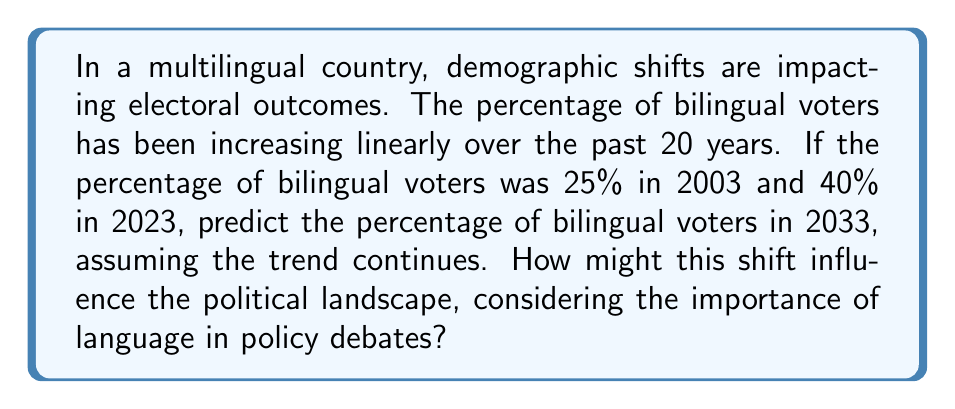Give your solution to this math problem. To solve this problem, we'll use linear trend analysis:

1. Calculate the rate of change:
   Let $y$ be the percentage of bilingual voters and $x$ be the years since 2003.
   
   Rate of change = $\frac{\text{Change in y}}{\text{Change in x}} = \frac{40\% - 25\%}{20 \text{ years}} = \frac{15\%}{20 \text{ years}} = 0.75\% \text{ per year}$

2. Form the linear equation:
   $y = mx + b$, where $m$ is the rate of change and $b$ is the y-intercept (percentage in 2003)
   
   $y = 0.75x + 25$

3. Predict the percentage for 2033:
   2033 is 30 years after 2003, so $x = 30$
   
   $y = 0.75(30) + 25 = 22.5 + 25 = 47.5\%$

The linear trend predicts that 47.5% of voters will be bilingual by 2033.

Political implications:
This shift could significantly influence the political landscape. With nearly half the electorate being bilingual, there may be:
- Increased demand for multilingual political communications
- Greater focus on language rights and policies
- Potential changes in coalition-building strategies
- More nuanced debates on language-related issues

Politicians and parties may need to adapt their messaging and policy positions to appeal to this growing bilingual demographic.
Answer: 47.5% 